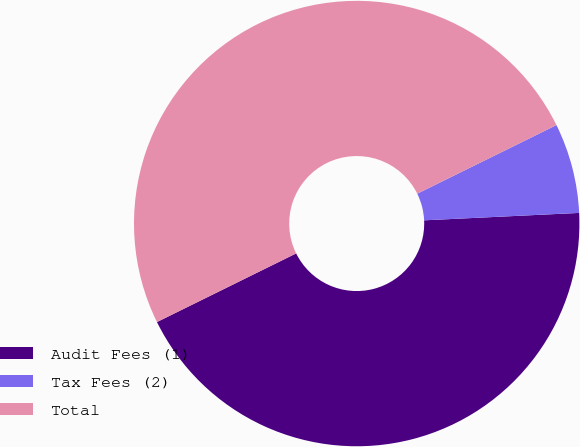<chart> <loc_0><loc_0><loc_500><loc_500><pie_chart><fcel>Audit Fees (1)<fcel>Tax Fees (2)<fcel>Total<nl><fcel>43.47%<fcel>6.53%<fcel>50.0%<nl></chart> 